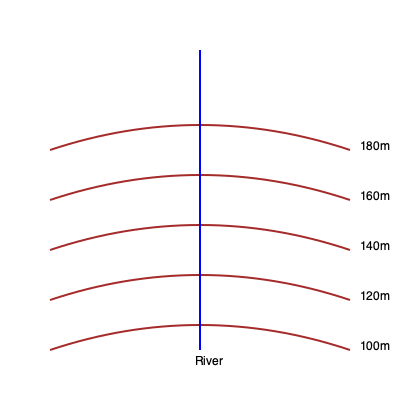Analyze the topographical map of a small Kurdish town situated along a river. The contour interval is 20 meters. Determine the average slope between points A (100m elevation) and B (180m elevation), which are 300 meters apart horizontally along the blue line representing the river. Express your answer as a percentage. To calculate the average slope between points A and B, we need to follow these steps:

1. Determine the change in elevation:
   Elevation at B = 180m
   Elevation at A = 100m
   Change in elevation = 180m - 100m = 80m

2. Identify the horizontal distance:
   The question states that points A and B are 300 meters apart horizontally.

3. Calculate the slope using the formula:
   Slope = (Change in elevation / Horizontal distance) × 100%
   
4. Plug in the values:
   Slope = (80m / 300m) × 100%
   
5. Perform the calculation:
   Slope = 0.2667 × 100% = 26.67%

Therefore, the average slope between points A and B is approximately 26.67%.
Answer: 26.67% 